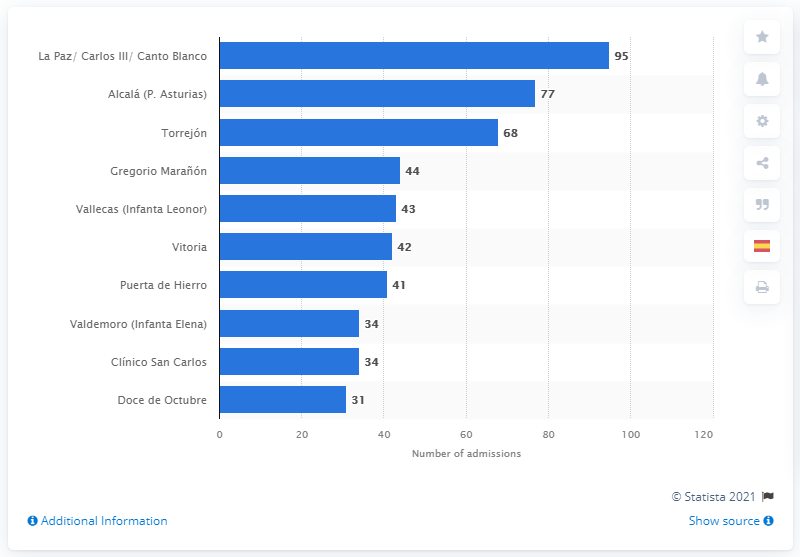Identify some key points in this picture. As of March 12, 2020, a total of 95 patients were admitted to the La Paz/Carlos III/Canto Blanco hospital. 